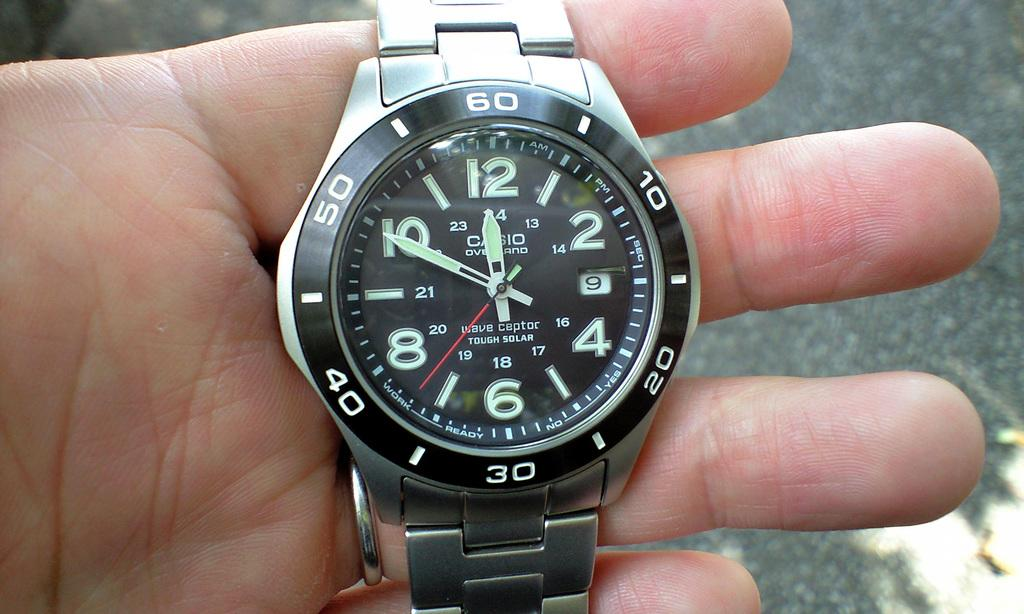<image>
Create a compact narrative representing the image presented. Hand holding a watch in his hand with the timer saying 12:50 